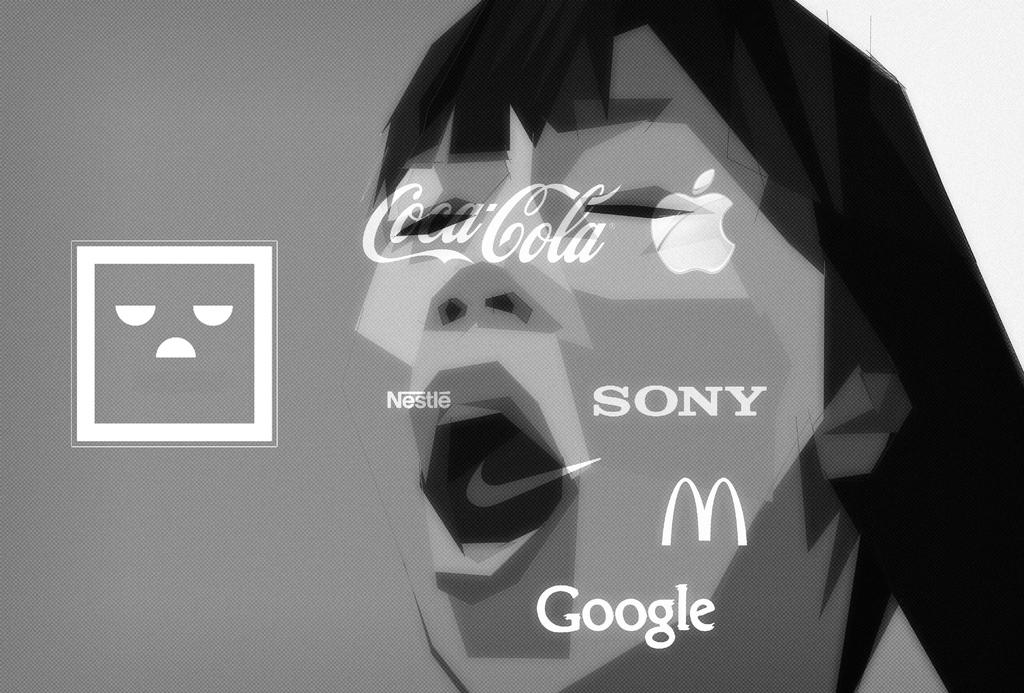What type of image is being described? The image is graphical in nature. What other elements can be found in the image? There is text and symbols in the image. Are there any human-like figures in the image? Yes, there is an image of a human in the image. What type of coal is being mined by the human in the image? There is no human mining coal in the image, nor is there any coal present. 